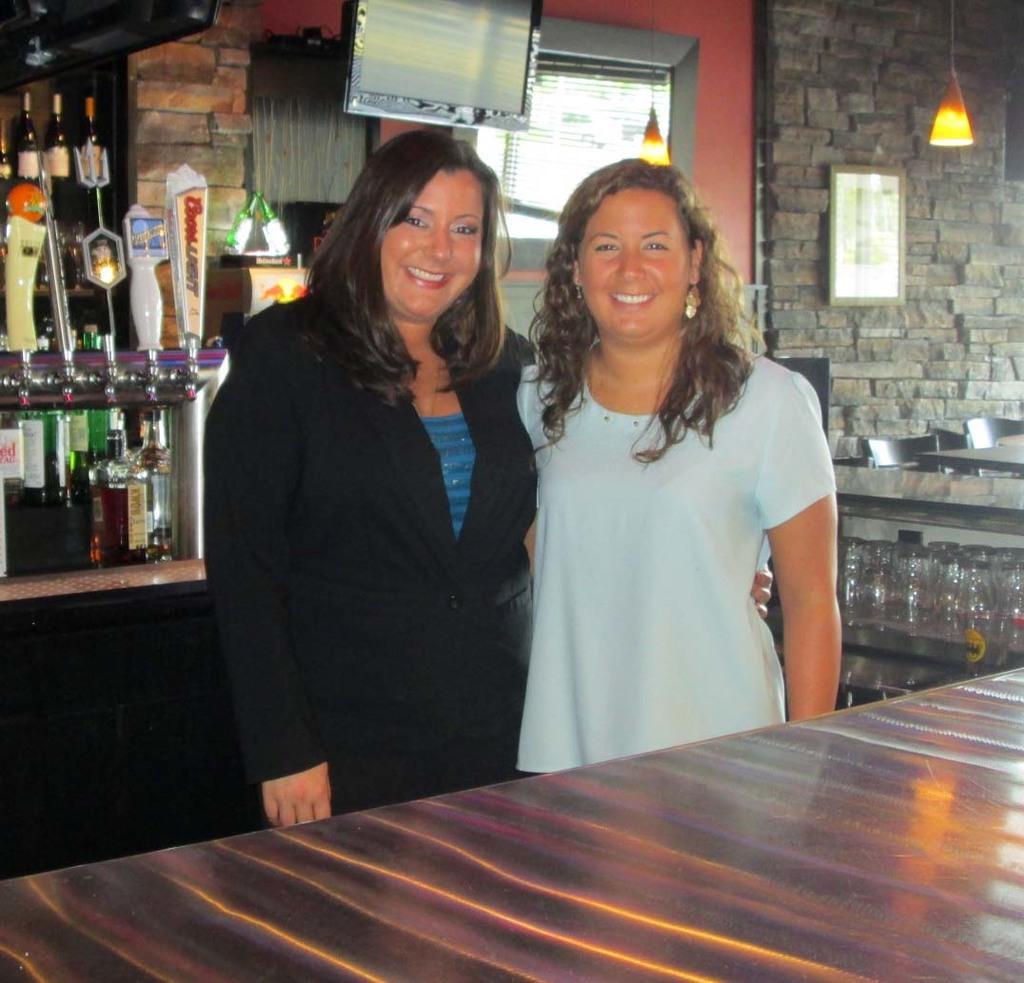In one or two sentences, can you explain what this image depicts? In the background we can see a frame on the wall. In this picture we can see the screens, lights, bottles, chairs, objects, tables and glasses. We can see women are standing and smiling. At the bottom portion of the picture it looks like a table. 